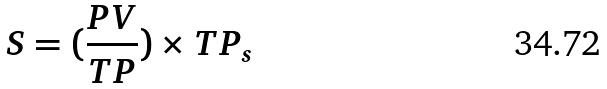<formula> <loc_0><loc_0><loc_500><loc_500>S = ( \frac { P V } { T P } ) \times T P _ { s }</formula> 